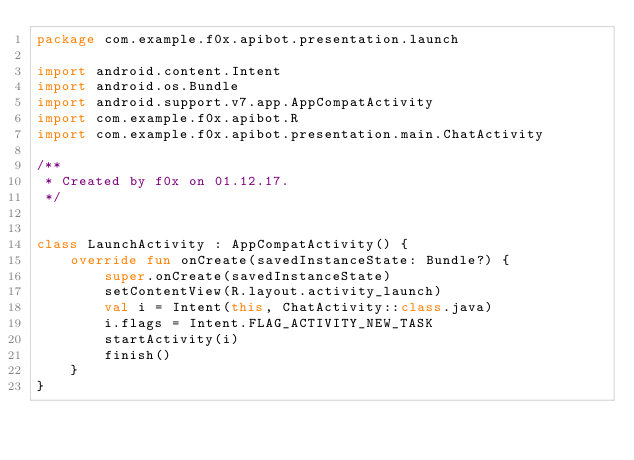<code> <loc_0><loc_0><loc_500><loc_500><_Kotlin_>package com.example.f0x.apibot.presentation.launch

import android.content.Intent
import android.os.Bundle
import android.support.v7.app.AppCompatActivity
import com.example.f0x.apibot.R
import com.example.f0x.apibot.presentation.main.ChatActivity

/**
 * Created by f0x on 01.12.17.
 */


class LaunchActivity : AppCompatActivity() {
    override fun onCreate(savedInstanceState: Bundle?) {
        super.onCreate(savedInstanceState)
        setContentView(R.layout.activity_launch)
        val i = Intent(this, ChatActivity::class.java)
        i.flags = Intent.FLAG_ACTIVITY_NEW_TASK
        startActivity(i)
        finish()
    }
}</code> 